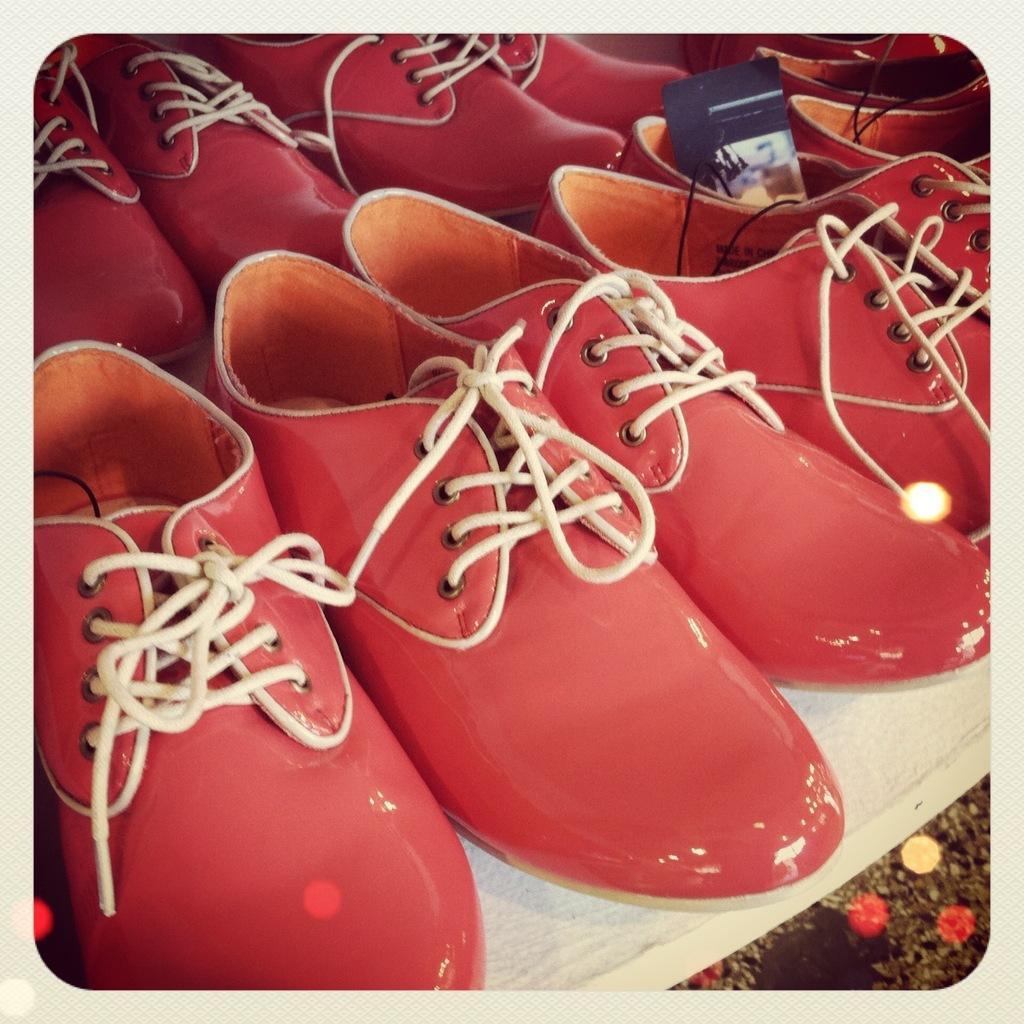In one or two sentences, can you explain what this image depicts? In this image we can see shoes placed on the table. 